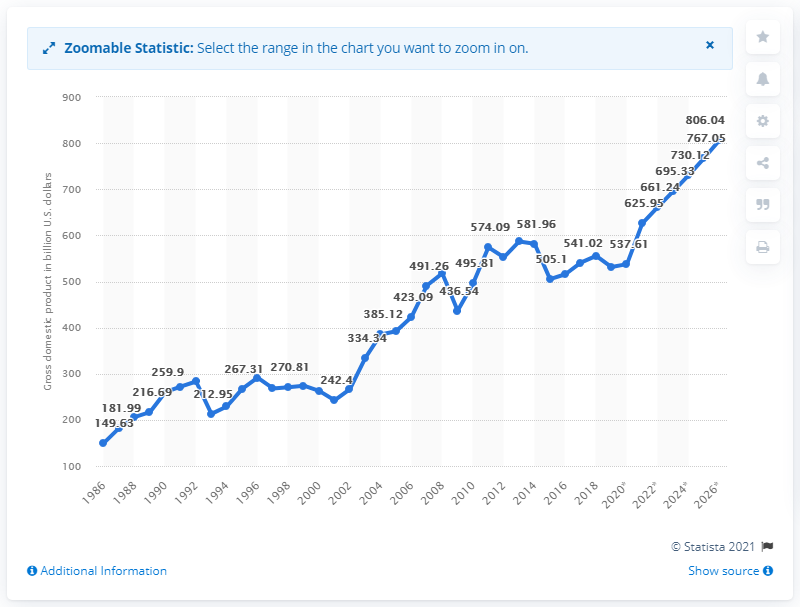Identify some key points in this picture. In 2019, the gross domestic product of Sweden was 531.28. 